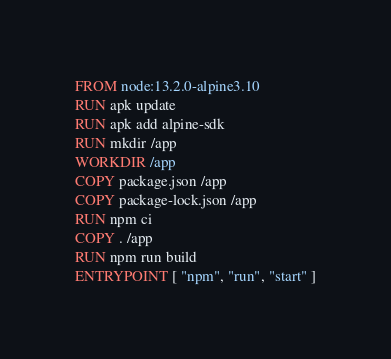Convert code to text. <code><loc_0><loc_0><loc_500><loc_500><_Dockerfile_>FROM node:13.2.0-alpine3.10
RUN apk update
RUN apk add alpine-sdk
RUN mkdir /app
WORKDIR /app
COPY package.json /app
COPY package-lock.json /app
RUN npm ci
COPY . /app
RUN npm run build
ENTRYPOINT [ "npm", "run", "start" ]</code> 